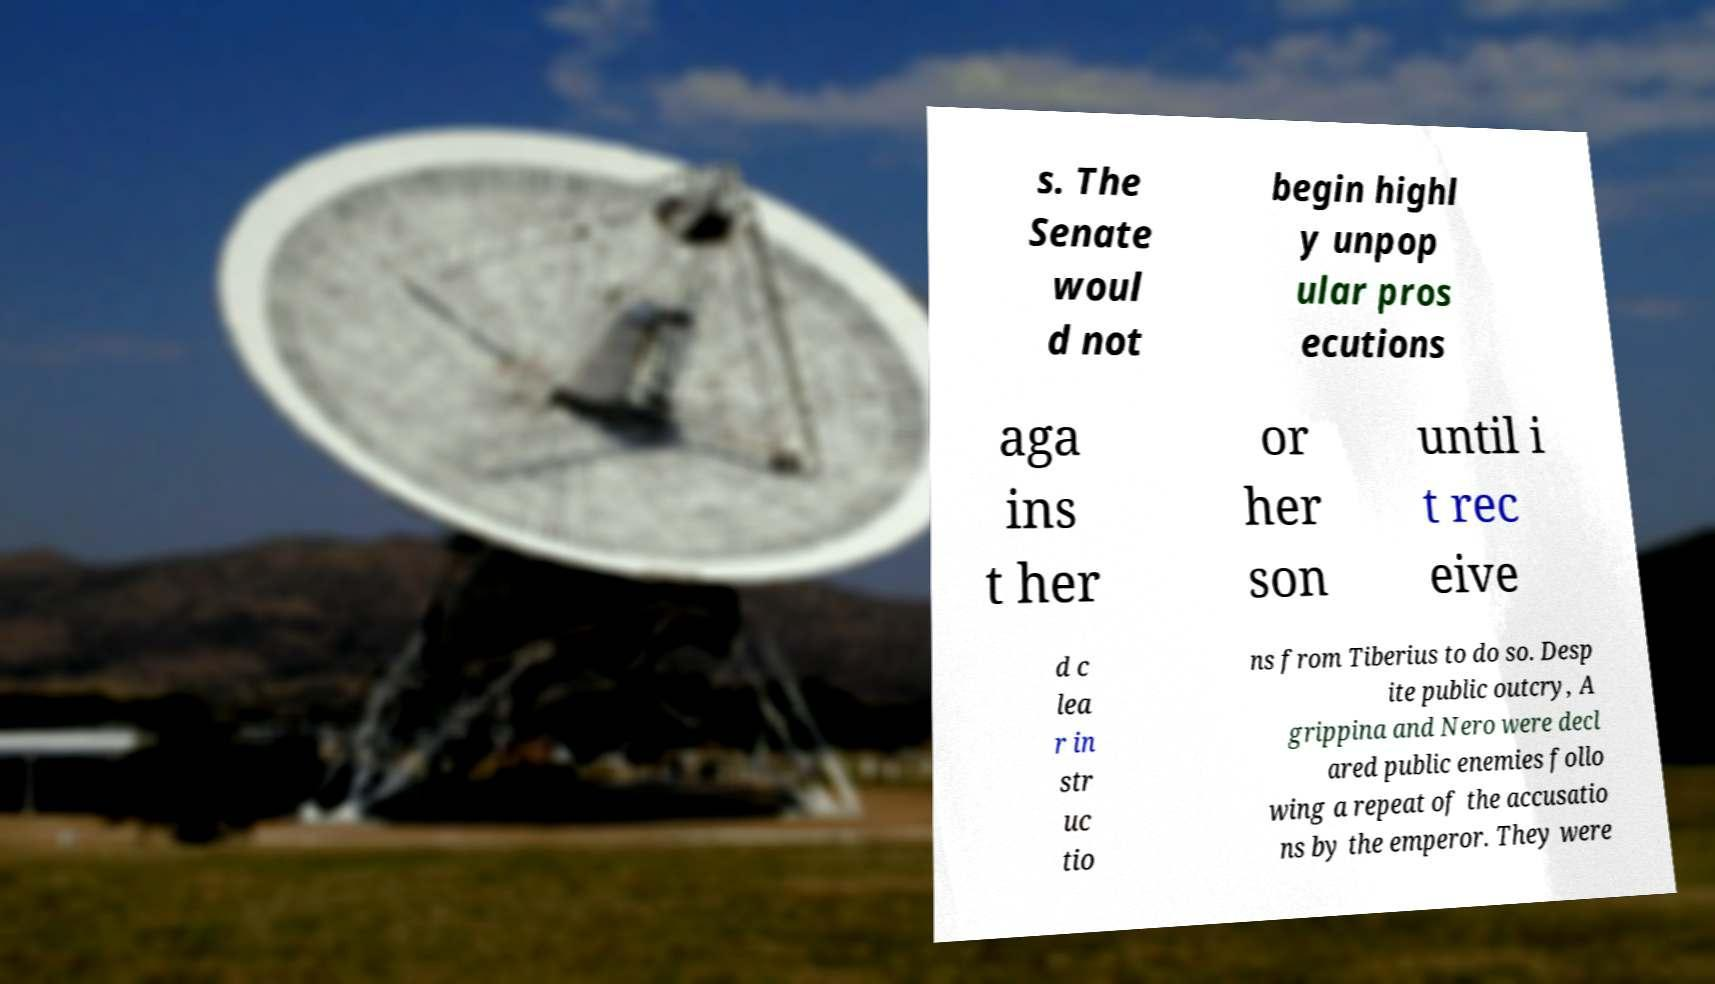Could you extract and type out the text from this image? s. The Senate woul d not begin highl y unpop ular pros ecutions aga ins t her or her son until i t rec eive d c lea r in str uc tio ns from Tiberius to do so. Desp ite public outcry, A grippina and Nero were decl ared public enemies follo wing a repeat of the accusatio ns by the emperor. They were 